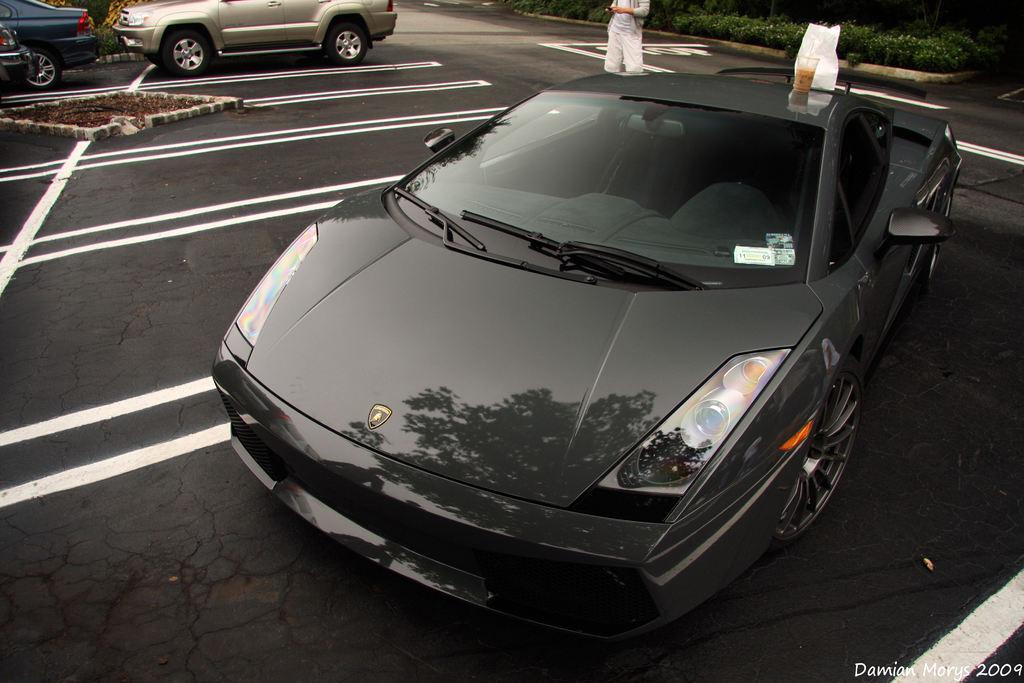Can you describe this image briefly? This image is clicked on the road. There are cars parked on the road. Behind the car there is a person standing. Behind the person there is grass on the ground. On the top of the car there is a cover. Beside it there is a glass. In the bottom right there is text on the image. 